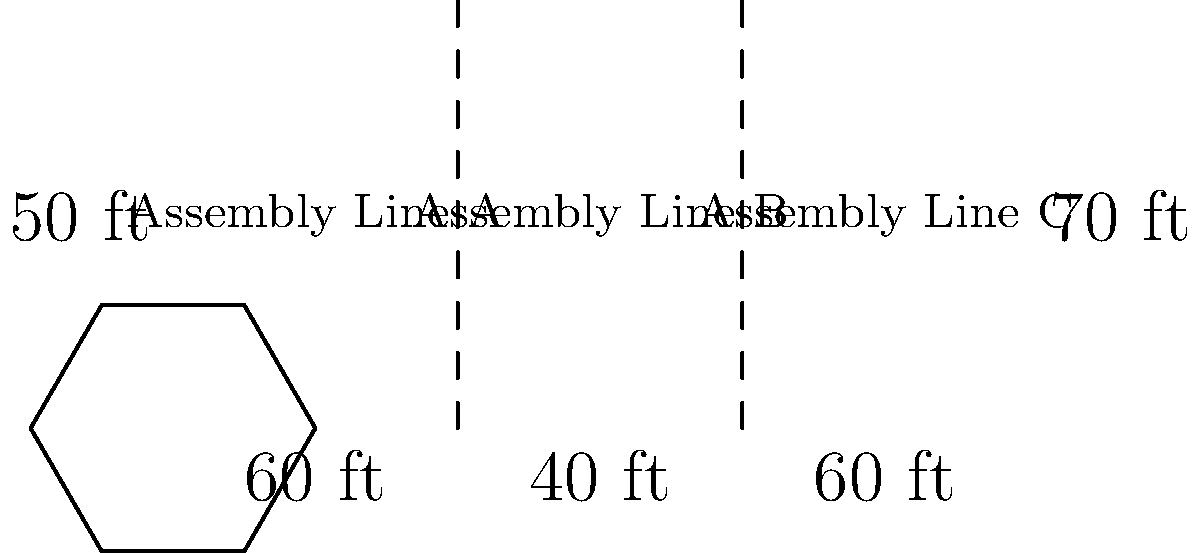As a dedicated factory worker, you're tasked with calculating the perimeter of your factory's floor plan to ensure proper safety measures are in place. The factory floor is divided into three assembly lines as shown in the diagram. What is the total perimeter of the factory floor in feet? To find the perimeter of the factory floor, we need to add up the lengths of all sides:

1. Bottom side: $60 \text{ ft} + 40 \text{ ft} + 60 \text{ ft} = 160 \text{ ft}$
2. Top side: $160 \text{ ft}$ (same as bottom side)
3. Left side: $50 \text{ ft}$
4. Right side: $70 \text{ ft}$

Now, we can calculate the total perimeter:

$$\text{Perimeter} = 160 \text{ ft} + 160 \text{ ft} + 50 \text{ ft} + 70 \text{ ft} = 440 \text{ ft}$$

Therefore, the total perimeter of the factory floor is 440 feet.
Answer: 440 ft 